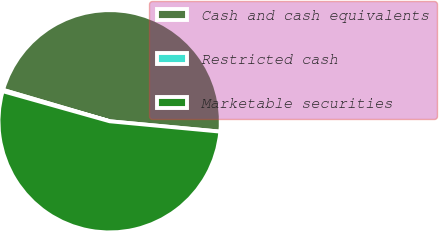<chart> <loc_0><loc_0><loc_500><loc_500><pie_chart><fcel>Cash and cash equivalents<fcel>Restricted cash<fcel>Marketable securities<nl><fcel>46.93%<fcel>0.19%<fcel>52.88%<nl></chart> 